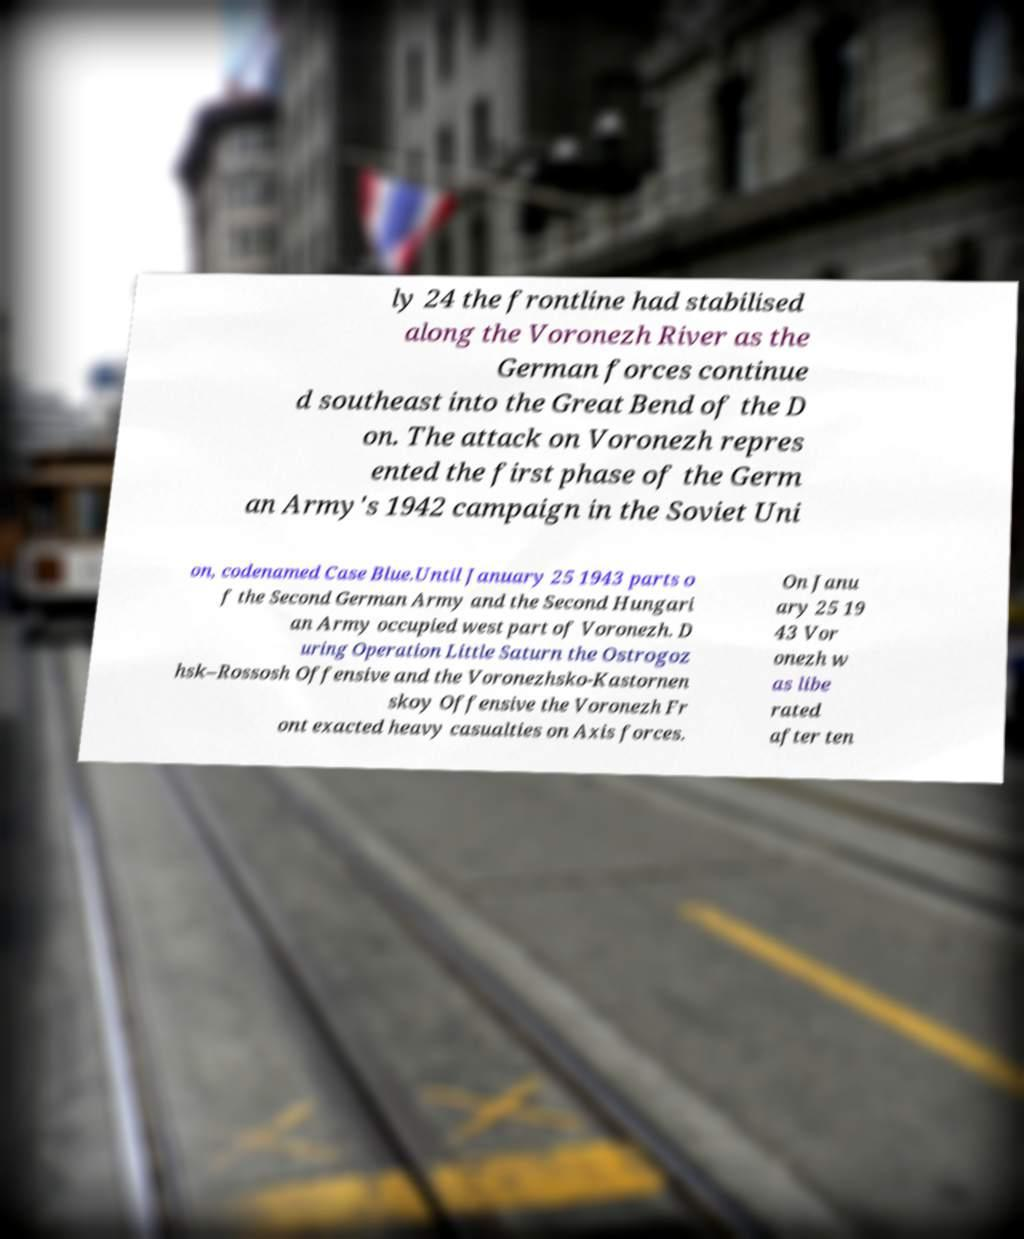What messages or text are displayed in this image? I need them in a readable, typed format. ly 24 the frontline had stabilised along the Voronezh River as the German forces continue d southeast into the Great Bend of the D on. The attack on Voronezh repres ented the first phase of the Germ an Army's 1942 campaign in the Soviet Uni on, codenamed Case Blue.Until January 25 1943 parts o f the Second German Army and the Second Hungari an Army occupied west part of Voronezh. D uring Operation Little Saturn the Ostrogoz hsk–Rossosh Offensive and the Voronezhsko-Kastornen skoy Offensive the Voronezh Fr ont exacted heavy casualties on Axis forces. On Janu ary 25 19 43 Vor onezh w as libe rated after ten 